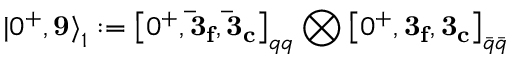<formula> <loc_0><loc_0><loc_500><loc_500>{ | 0 ^ { + } , { 9 } \rangle } _ { 1 } \colon = { \left [ 0 ^ { + } , { \bar { 3 } _ { f } } , { \bar { 3 } _ { c } } \right ] } _ { q q } \bigotimes { \left [ 0 ^ { + } , { 3 _ { f } } , { 3 _ { c } } \right ] } _ { \bar { q } \bar { q } }</formula> 